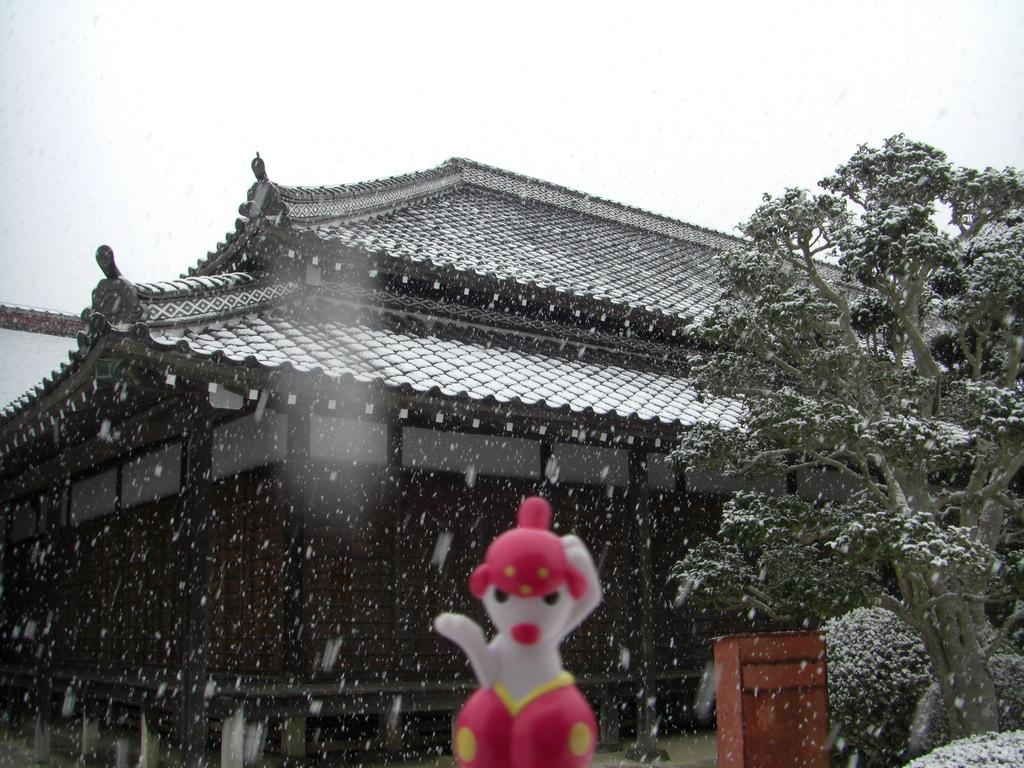What type of structure is visible in the image? There is a house in the image. What can be seen on the right side of the image? There is a tree on the right side of the image. What object is located in the front of the image? There is a doll in the front of the image. What is happening in the image due to the weather? It is snowing in the image. What is visible at the top of the image? The sky is visible at the top of the image. Who is the manager of the doll in the image? There is no indication of a manager in the image, as it features a house, a tree, a doll, and snowing weather. Did the doll receive approval from the tree in the image? There is no indication of approval or any interaction between the doll and the tree in the image. 